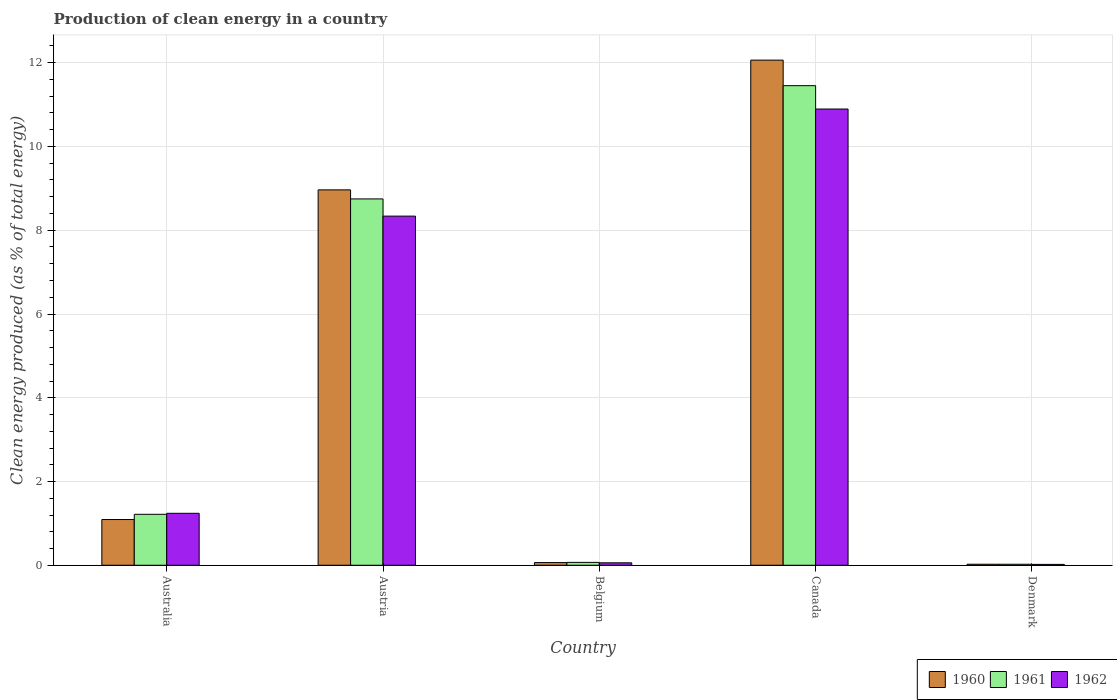How many different coloured bars are there?
Make the answer very short. 3. Are the number of bars per tick equal to the number of legend labels?
Give a very brief answer. Yes. Are the number of bars on each tick of the X-axis equal?
Your response must be concise. Yes. How many bars are there on the 2nd tick from the left?
Keep it short and to the point. 3. What is the label of the 4th group of bars from the left?
Your answer should be compact. Canada. In how many cases, is the number of bars for a given country not equal to the number of legend labels?
Your response must be concise. 0. What is the percentage of clean energy produced in 1960 in Canada?
Your answer should be compact. 12.06. Across all countries, what is the maximum percentage of clean energy produced in 1960?
Provide a succinct answer. 12.06. Across all countries, what is the minimum percentage of clean energy produced in 1960?
Your answer should be compact. 0.02. In which country was the percentage of clean energy produced in 1961 maximum?
Your answer should be very brief. Canada. What is the total percentage of clean energy produced in 1960 in the graph?
Your answer should be compact. 22.21. What is the difference between the percentage of clean energy produced in 1962 in Australia and that in Belgium?
Offer a very short reply. 1.18. What is the difference between the percentage of clean energy produced in 1962 in Belgium and the percentage of clean energy produced in 1961 in Australia?
Give a very brief answer. -1.16. What is the average percentage of clean energy produced in 1962 per country?
Keep it short and to the point. 4.11. What is the difference between the percentage of clean energy produced of/in 1960 and percentage of clean energy produced of/in 1962 in Denmark?
Offer a very short reply. 0. What is the ratio of the percentage of clean energy produced in 1961 in Australia to that in Denmark?
Ensure brevity in your answer.  50.77. Is the percentage of clean energy produced in 1961 in Australia less than that in Canada?
Make the answer very short. Yes. Is the difference between the percentage of clean energy produced in 1960 in Australia and Austria greater than the difference between the percentage of clean energy produced in 1962 in Australia and Austria?
Your answer should be compact. No. What is the difference between the highest and the second highest percentage of clean energy produced in 1961?
Ensure brevity in your answer.  7.53. What is the difference between the highest and the lowest percentage of clean energy produced in 1960?
Your answer should be compact. 12.04. What does the 2nd bar from the right in Australia represents?
Make the answer very short. 1961. How many bars are there?
Offer a terse response. 15. How many countries are there in the graph?
Offer a terse response. 5. Are the values on the major ticks of Y-axis written in scientific E-notation?
Offer a very short reply. No. Does the graph contain any zero values?
Your answer should be compact. No. What is the title of the graph?
Keep it short and to the point. Production of clean energy in a country. What is the label or title of the Y-axis?
Make the answer very short. Clean energy produced (as % of total energy). What is the Clean energy produced (as % of total energy) of 1960 in Australia?
Your answer should be compact. 1.09. What is the Clean energy produced (as % of total energy) in 1961 in Australia?
Your answer should be compact. 1.22. What is the Clean energy produced (as % of total energy) in 1962 in Australia?
Offer a terse response. 1.24. What is the Clean energy produced (as % of total energy) of 1960 in Austria?
Your answer should be very brief. 8.96. What is the Clean energy produced (as % of total energy) in 1961 in Austria?
Make the answer very short. 8.75. What is the Clean energy produced (as % of total energy) of 1962 in Austria?
Make the answer very short. 8.34. What is the Clean energy produced (as % of total energy) of 1960 in Belgium?
Your response must be concise. 0.06. What is the Clean energy produced (as % of total energy) of 1961 in Belgium?
Offer a terse response. 0.07. What is the Clean energy produced (as % of total energy) in 1962 in Belgium?
Provide a succinct answer. 0.06. What is the Clean energy produced (as % of total energy) of 1960 in Canada?
Provide a succinct answer. 12.06. What is the Clean energy produced (as % of total energy) of 1961 in Canada?
Ensure brevity in your answer.  11.45. What is the Clean energy produced (as % of total energy) in 1962 in Canada?
Give a very brief answer. 10.89. What is the Clean energy produced (as % of total energy) in 1960 in Denmark?
Your answer should be compact. 0.02. What is the Clean energy produced (as % of total energy) of 1961 in Denmark?
Ensure brevity in your answer.  0.02. What is the Clean energy produced (as % of total energy) of 1962 in Denmark?
Give a very brief answer. 0.02. Across all countries, what is the maximum Clean energy produced (as % of total energy) in 1960?
Your answer should be compact. 12.06. Across all countries, what is the maximum Clean energy produced (as % of total energy) in 1961?
Give a very brief answer. 11.45. Across all countries, what is the maximum Clean energy produced (as % of total energy) in 1962?
Make the answer very short. 10.89. Across all countries, what is the minimum Clean energy produced (as % of total energy) in 1960?
Offer a very short reply. 0.02. Across all countries, what is the minimum Clean energy produced (as % of total energy) in 1961?
Your response must be concise. 0.02. Across all countries, what is the minimum Clean energy produced (as % of total energy) of 1962?
Make the answer very short. 0.02. What is the total Clean energy produced (as % of total energy) in 1960 in the graph?
Make the answer very short. 22.21. What is the total Clean energy produced (as % of total energy) of 1961 in the graph?
Your answer should be compact. 21.51. What is the total Clean energy produced (as % of total energy) of 1962 in the graph?
Provide a succinct answer. 20.55. What is the difference between the Clean energy produced (as % of total energy) of 1960 in Australia and that in Austria?
Offer a very short reply. -7.87. What is the difference between the Clean energy produced (as % of total energy) of 1961 in Australia and that in Austria?
Offer a very short reply. -7.53. What is the difference between the Clean energy produced (as % of total energy) of 1962 in Australia and that in Austria?
Offer a terse response. -7.1. What is the difference between the Clean energy produced (as % of total energy) of 1960 in Australia and that in Belgium?
Give a very brief answer. 1.03. What is the difference between the Clean energy produced (as % of total energy) in 1961 in Australia and that in Belgium?
Your answer should be compact. 1.15. What is the difference between the Clean energy produced (as % of total energy) in 1962 in Australia and that in Belgium?
Make the answer very short. 1.18. What is the difference between the Clean energy produced (as % of total energy) of 1960 in Australia and that in Canada?
Give a very brief answer. -10.97. What is the difference between the Clean energy produced (as % of total energy) of 1961 in Australia and that in Canada?
Offer a terse response. -10.24. What is the difference between the Clean energy produced (as % of total energy) in 1962 in Australia and that in Canada?
Make the answer very short. -9.65. What is the difference between the Clean energy produced (as % of total energy) of 1960 in Australia and that in Denmark?
Ensure brevity in your answer.  1.07. What is the difference between the Clean energy produced (as % of total energy) of 1961 in Australia and that in Denmark?
Provide a succinct answer. 1.19. What is the difference between the Clean energy produced (as % of total energy) in 1962 in Australia and that in Denmark?
Your answer should be very brief. 1.22. What is the difference between the Clean energy produced (as % of total energy) in 1960 in Austria and that in Belgium?
Your answer should be compact. 8.9. What is the difference between the Clean energy produced (as % of total energy) in 1961 in Austria and that in Belgium?
Offer a terse response. 8.68. What is the difference between the Clean energy produced (as % of total energy) of 1962 in Austria and that in Belgium?
Offer a very short reply. 8.28. What is the difference between the Clean energy produced (as % of total energy) in 1960 in Austria and that in Canada?
Provide a short and direct response. -3.1. What is the difference between the Clean energy produced (as % of total energy) of 1961 in Austria and that in Canada?
Your answer should be compact. -2.7. What is the difference between the Clean energy produced (as % of total energy) in 1962 in Austria and that in Canada?
Give a very brief answer. -2.56. What is the difference between the Clean energy produced (as % of total energy) in 1960 in Austria and that in Denmark?
Your answer should be compact. 8.94. What is the difference between the Clean energy produced (as % of total energy) of 1961 in Austria and that in Denmark?
Provide a short and direct response. 8.72. What is the difference between the Clean energy produced (as % of total energy) of 1962 in Austria and that in Denmark?
Keep it short and to the point. 8.32. What is the difference between the Clean energy produced (as % of total energy) of 1960 in Belgium and that in Canada?
Your answer should be very brief. -12. What is the difference between the Clean energy produced (as % of total energy) of 1961 in Belgium and that in Canada?
Your answer should be compact. -11.38. What is the difference between the Clean energy produced (as % of total energy) in 1962 in Belgium and that in Canada?
Your answer should be very brief. -10.84. What is the difference between the Clean energy produced (as % of total energy) in 1960 in Belgium and that in Denmark?
Ensure brevity in your answer.  0.04. What is the difference between the Clean energy produced (as % of total energy) of 1961 in Belgium and that in Denmark?
Your response must be concise. 0.04. What is the difference between the Clean energy produced (as % of total energy) in 1962 in Belgium and that in Denmark?
Your answer should be very brief. 0.04. What is the difference between the Clean energy produced (as % of total energy) of 1960 in Canada and that in Denmark?
Give a very brief answer. 12.04. What is the difference between the Clean energy produced (as % of total energy) in 1961 in Canada and that in Denmark?
Your response must be concise. 11.43. What is the difference between the Clean energy produced (as % of total energy) in 1962 in Canada and that in Denmark?
Give a very brief answer. 10.87. What is the difference between the Clean energy produced (as % of total energy) of 1960 in Australia and the Clean energy produced (as % of total energy) of 1961 in Austria?
Your response must be concise. -7.66. What is the difference between the Clean energy produced (as % of total energy) in 1960 in Australia and the Clean energy produced (as % of total energy) in 1962 in Austria?
Your answer should be very brief. -7.25. What is the difference between the Clean energy produced (as % of total energy) in 1961 in Australia and the Clean energy produced (as % of total energy) in 1962 in Austria?
Your answer should be very brief. -7.12. What is the difference between the Clean energy produced (as % of total energy) in 1960 in Australia and the Clean energy produced (as % of total energy) in 1961 in Belgium?
Offer a very short reply. 1.02. What is the difference between the Clean energy produced (as % of total energy) in 1960 in Australia and the Clean energy produced (as % of total energy) in 1962 in Belgium?
Provide a succinct answer. 1.03. What is the difference between the Clean energy produced (as % of total energy) of 1961 in Australia and the Clean energy produced (as % of total energy) of 1962 in Belgium?
Give a very brief answer. 1.16. What is the difference between the Clean energy produced (as % of total energy) in 1960 in Australia and the Clean energy produced (as % of total energy) in 1961 in Canada?
Provide a short and direct response. -10.36. What is the difference between the Clean energy produced (as % of total energy) of 1960 in Australia and the Clean energy produced (as % of total energy) of 1962 in Canada?
Give a very brief answer. -9.8. What is the difference between the Clean energy produced (as % of total energy) of 1961 in Australia and the Clean energy produced (as % of total energy) of 1962 in Canada?
Provide a succinct answer. -9.68. What is the difference between the Clean energy produced (as % of total energy) of 1960 in Australia and the Clean energy produced (as % of total energy) of 1961 in Denmark?
Offer a terse response. 1.07. What is the difference between the Clean energy produced (as % of total energy) of 1960 in Australia and the Clean energy produced (as % of total energy) of 1962 in Denmark?
Provide a short and direct response. 1.07. What is the difference between the Clean energy produced (as % of total energy) in 1961 in Australia and the Clean energy produced (as % of total energy) in 1962 in Denmark?
Ensure brevity in your answer.  1.2. What is the difference between the Clean energy produced (as % of total energy) in 1960 in Austria and the Clean energy produced (as % of total energy) in 1961 in Belgium?
Your answer should be very brief. 8.9. What is the difference between the Clean energy produced (as % of total energy) of 1960 in Austria and the Clean energy produced (as % of total energy) of 1962 in Belgium?
Keep it short and to the point. 8.91. What is the difference between the Clean energy produced (as % of total energy) of 1961 in Austria and the Clean energy produced (as % of total energy) of 1962 in Belgium?
Make the answer very short. 8.69. What is the difference between the Clean energy produced (as % of total energy) of 1960 in Austria and the Clean energy produced (as % of total energy) of 1961 in Canada?
Provide a short and direct response. -2.49. What is the difference between the Clean energy produced (as % of total energy) in 1960 in Austria and the Clean energy produced (as % of total energy) in 1962 in Canada?
Offer a terse response. -1.93. What is the difference between the Clean energy produced (as % of total energy) of 1961 in Austria and the Clean energy produced (as % of total energy) of 1962 in Canada?
Offer a terse response. -2.15. What is the difference between the Clean energy produced (as % of total energy) in 1960 in Austria and the Clean energy produced (as % of total energy) in 1961 in Denmark?
Your answer should be compact. 8.94. What is the difference between the Clean energy produced (as % of total energy) of 1960 in Austria and the Clean energy produced (as % of total energy) of 1962 in Denmark?
Keep it short and to the point. 8.94. What is the difference between the Clean energy produced (as % of total energy) of 1961 in Austria and the Clean energy produced (as % of total energy) of 1962 in Denmark?
Provide a succinct answer. 8.73. What is the difference between the Clean energy produced (as % of total energy) in 1960 in Belgium and the Clean energy produced (as % of total energy) in 1961 in Canada?
Ensure brevity in your answer.  -11.39. What is the difference between the Clean energy produced (as % of total energy) of 1960 in Belgium and the Clean energy produced (as % of total energy) of 1962 in Canada?
Provide a short and direct response. -10.83. What is the difference between the Clean energy produced (as % of total energy) in 1961 in Belgium and the Clean energy produced (as % of total energy) in 1962 in Canada?
Give a very brief answer. -10.83. What is the difference between the Clean energy produced (as % of total energy) in 1960 in Belgium and the Clean energy produced (as % of total energy) in 1961 in Denmark?
Keep it short and to the point. 0.04. What is the difference between the Clean energy produced (as % of total energy) of 1960 in Belgium and the Clean energy produced (as % of total energy) of 1962 in Denmark?
Your response must be concise. 0.04. What is the difference between the Clean energy produced (as % of total energy) of 1961 in Belgium and the Clean energy produced (as % of total energy) of 1962 in Denmark?
Provide a succinct answer. 0.05. What is the difference between the Clean energy produced (as % of total energy) of 1960 in Canada and the Clean energy produced (as % of total energy) of 1961 in Denmark?
Ensure brevity in your answer.  12.04. What is the difference between the Clean energy produced (as % of total energy) in 1960 in Canada and the Clean energy produced (as % of total energy) in 1962 in Denmark?
Your answer should be compact. 12.04. What is the difference between the Clean energy produced (as % of total energy) of 1961 in Canada and the Clean energy produced (as % of total energy) of 1962 in Denmark?
Your answer should be compact. 11.43. What is the average Clean energy produced (as % of total energy) of 1960 per country?
Make the answer very short. 4.44. What is the average Clean energy produced (as % of total energy) in 1961 per country?
Offer a very short reply. 4.3. What is the average Clean energy produced (as % of total energy) in 1962 per country?
Give a very brief answer. 4.11. What is the difference between the Clean energy produced (as % of total energy) of 1960 and Clean energy produced (as % of total energy) of 1961 in Australia?
Provide a succinct answer. -0.12. What is the difference between the Clean energy produced (as % of total energy) of 1960 and Clean energy produced (as % of total energy) of 1962 in Australia?
Provide a short and direct response. -0.15. What is the difference between the Clean energy produced (as % of total energy) of 1961 and Clean energy produced (as % of total energy) of 1962 in Australia?
Make the answer very short. -0.02. What is the difference between the Clean energy produced (as % of total energy) of 1960 and Clean energy produced (as % of total energy) of 1961 in Austria?
Offer a very short reply. 0.22. What is the difference between the Clean energy produced (as % of total energy) of 1960 and Clean energy produced (as % of total energy) of 1962 in Austria?
Give a very brief answer. 0.63. What is the difference between the Clean energy produced (as % of total energy) in 1961 and Clean energy produced (as % of total energy) in 1962 in Austria?
Offer a terse response. 0.41. What is the difference between the Clean energy produced (as % of total energy) in 1960 and Clean energy produced (as % of total energy) in 1961 in Belgium?
Give a very brief answer. -0. What is the difference between the Clean energy produced (as % of total energy) of 1960 and Clean energy produced (as % of total energy) of 1962 in Belgium?
Provide a short and direct response. 0.01. What is the difference between the Clean energy produced (as % of total energy) of 1961 and Clean energy produced (as % of total energy) of 1962 in Belgium?
Provide a short and direct response. 0.01. What is the difference between the Clean energy produced (as % of total energy) of 1960 and Clean energy produced (as % of total energy) of 1961 in Canada?
Your answer should be compact. 0.61. What is the difference between the Clean energy produced (as % of total energy) of 1960 and Clean energy produced (as % of total energy) of 1962 in Canada?
Provide a short and direct response. 1.17. What is the difference between the Clean energy produced (as % of total energy) of 1961 and Clean energy produced (as % of total energy) of 1962 in Canada?
Provide a short and direct response. 0.56. What is the difference between the Clean energy produced (as % of total energy) of 1960 and Clean energy produced (as % of total energy) of 1962 in Denmark?
Your answer should be very brief. 0. What is the difference between the Clean energy produced (as % of total energy) of 1961 and Clean energy produced (as % of total energy) of 1962 in Denmark?
Provide a short and direct response. 0. What is the ratio of the Clean energy produced (as % of total energy) of 1960 in Australia to that in Austria?
Offer a terse response. 0.12. What is the ratio of the Clean energy produced (as % of total energy) in 1961 in Australia to that in Austria?
Ensure brevity in your answer.  0.14. What is the ratio of the Clean energy produced (as % of total energy) of 1962 in Australia to that in Austria?
Keep it short and to the point. 0.15. What is the ratio of the Clean energy produced (as % of total energy) in 1960 in Australia to that in Belgium?
Offer a terse response. 17.03. What is the ratio of the Clean energy produced (as % of total energy) of 1961 in Australia to that in Belgium?
Provide a short and direct response. 17.67. What is the ratio of the Clean energy produced (as % of total energy) in 1962 in Australia to that in Belgium?
Provide a short and direct response. 21.34. What is the ratio of the Clean energy produced (as % of total energy) in 1960 in Australia to that in Canada?
Offer a very short reply. 0.09. What is the ratio of the Clean energy produced (as % of total energy) of 1961 in Australia to that in Canada?
Make the answer very short. 0.11. What is the ratio of the Clean energy produced (as % of total energy) of 1962 in Australia to that in Canada?
Make the answer very short. 0.11. What is the ratio of the Clean energy produced (as % of total energy) in 1960 in Australia to that in Denmark?
Keep it short and to the point. 44.73. What is the ratio of the Clean energy produced (as % of total energy) of 1961 in Australia to that in Denmark?
Provide a succinct answer. 50.77. What is the ratio of the Clean energy produced (as % of total energy) of 1962 in Australia to that in Denmark?
Offer a terse response. 59.22. What is the ratio of the Clean energy produced (as % of total energy) in 1960 in Austria to that in Belgium?
Your response must be concise. 139.76. What is the ratio of the Clean energy produced (as % of total energy) of 1961 in Austria to that in Belgium?
Offer a terse response. 127.07. What is the ratio of the Clean energy produced (as % of total energy) in 1962 in Austria to that in Belgium?
Offer a very short reply. 143.44. What is the ratio of the Clean energy produced (as % of total energy) in 1960 in Austria to that in Canada?
Give a very brief answer. 0.74. What is the ratio of the Clean energy produced (as % of total energy) of 1961 in Austria to that in Canada?
Give a very brief answer. 0.76. What is the ratio of the Clean energy produced (as % of total energy) of 1962 in Austria to that in Canada?
Your response must be concise. 0.77. What is the ratio of the Clean energy produced (as % of total energy) of 1960 in Austria to that in Denmark?
Your answer should be compact. 367.18. What is the ratio of the Clean energy produced (as % of total energy) of 1961 in Austria to that in Denmark?
Your answer should be very brief. 365.06. What is the ratio of the Clean energy produced (as % of total energy) in 1962 in Austria to that in Denmark?
Your response must be concise. 397.95. What is the ratio of the Clean energy produced (as % of total energy) in 1960 in Belgium to that in Canada?
Your answer should be very brief. 0.01. What is the ratio of the Clean energy produced (as % of total energy) in 1961 in Belgium to that in Canada?
Provide a short and direct response. 0.01. What is the ratio of the Clean energy produced (as % of total energy) in 1962 in Belgium to that in Canada?
Your answer should be very brief. 0.01. What is the ratio of the Clean energy produced (as % of total energy) of 1960 in Belgium to that in Denmark?
Your response must be concise. 2.63. What is the ratio of the Clean energy produced (as % of total energy) in 1961 in Belgium to that in Denmark?
Give a very brief answer. 2.87. What is the ratio of the Clean energy produced (as % of total energy) in 1962 in Belgium to that in Denmark?
Offer a terse response. 2.77. What is the ratio of the Clean energy produced (as % of total energy) in 1960 in Canada to that in Denmark?
Ensure brevity in your answer.  494.07. What is the ratio of the Clean energy produced (as % of total energy) in 1961 in Canada to that in Denmark?
Ensure brevity in your answer.  477.92. What is the ratio of the Clean energy produced (as % of total energy) in 1962 in Canada to that in Denmark?
Your answer should be very brief. 520.01. What is the difference between the highest and the second highest Clean energy produced (as % of total energy) of 1960?
Your answer should be compact. 3.1. What is the difference between the highest and the second highest Clean energy produced (as % of total energy) of 1961?
Provide a succinct answer. 2.7. What is the difference between the highest and the second highest Clean energy produced (as % of total energy) in 1962?
Provide a succinct answer. 2.56. What is the difference between the highest and the lowest Clean energy produced (as % of total energy) of 1960?
Offer a very short reply. 12.04. What is the difference between the highest and the lowest Clean energy produced (as % of total energy) of 1961?
Provide a short and direct response. 11.43. What is the difference between the highest and the lowest Clean energy produced (as % of total energy) in 1962?
Give a very brief answer. 10.87. 